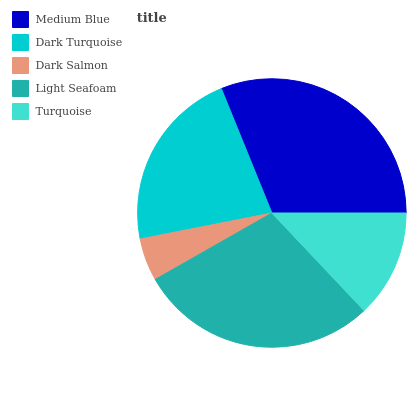Is Dark Salmon the minimum?
Answer yes or no. Yes. Is Medium Blue the maximum?
Answer yes or no. Yes. Is Dark Turquoise the minimum?
Answer yes or no. No. Is Dark Turquoise the maximum?
Answer yes or no. No. Is Medium Blue greater than Dark Turquoise?
Answer yes or no. Yes. Is Dark Turquoise less than Medium Blue?
Answer yes or no. Yes. Is Dark Turquoise greater than Medium Blue?
Answer yes or no. No. Is Medium Blue less than Dark Turquoise?
Answer yes or no. No. Is Dark Turquoise the high median?
Answer yes or no. Yes. Is Dark Turquoise the low median?
Answer yes or no. Yes. Is Medium Blue the high median?
Answer yes or no. No. Is Turquoise the low median?
Answer yes or no. No. 